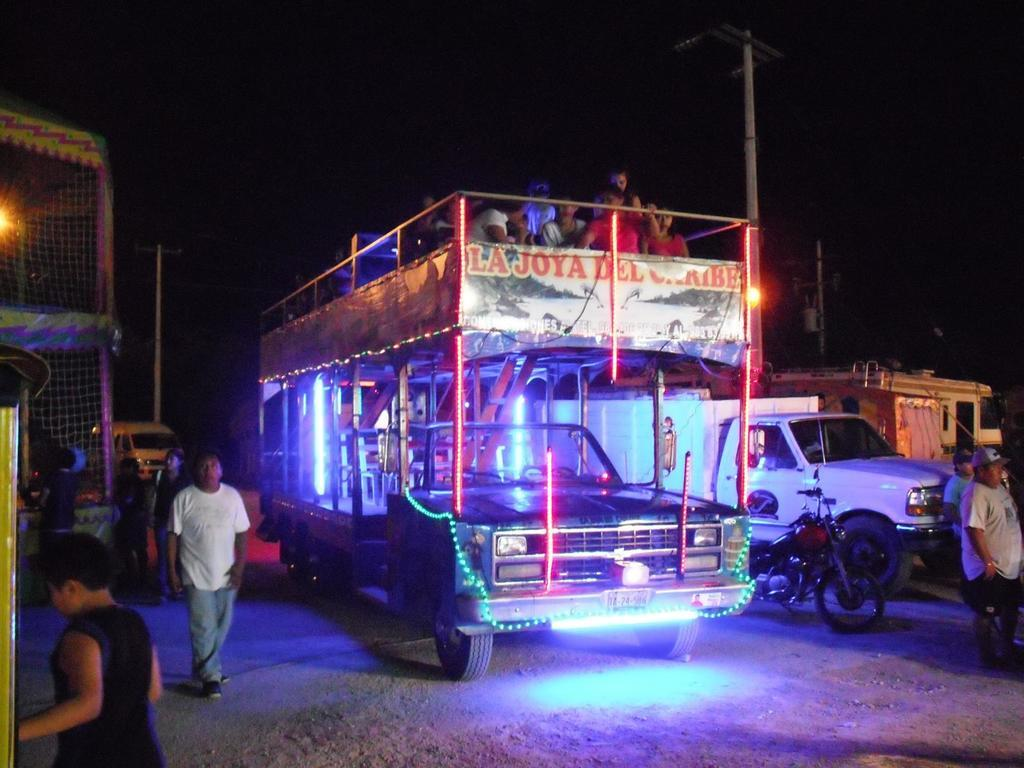What can be seen on the road in the image? There are vehicles on the road in the image. What else is present in the image besides the vehicles? There are lights, poles, a net, and people in the image. What might the lights be used for in the image? The lights could be used for illumination or signaling purposes. What is the background of the image like? The background of the image is dark. What type of tramp is visible in the image? There is no tramp present in the image. What dish is the cook preparing in the image? There is no cook or dish preparation visible in the image. 